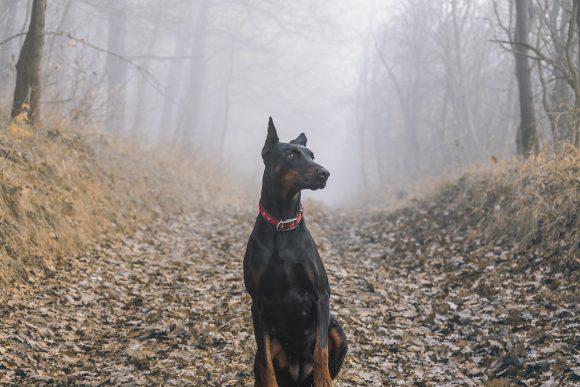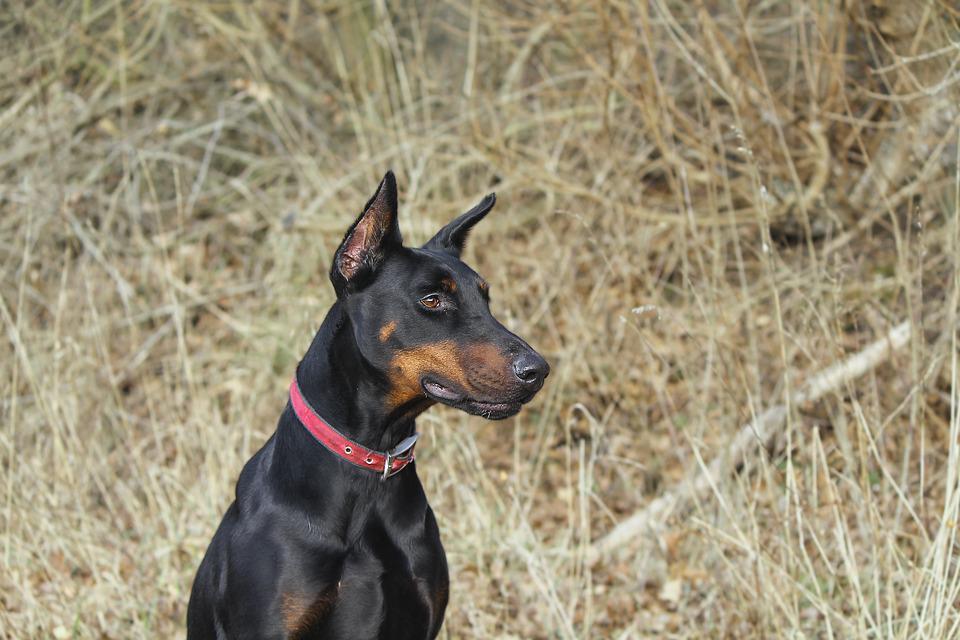The first image is the image on the left, the second image is the image on the right. For the images shown, is this caption "All dogs shown are erect-eared dobermans gazing off to the side, and at least one dog is wearing a red collar and has a closed mouth." true? Answer yes or no. Yes. The first image is the image on the left, the second image is the image on the right. Analyze the images presented: Is the assertion "The dog in the image on the right has its mouth open." valid? Answer yes or no. No. 